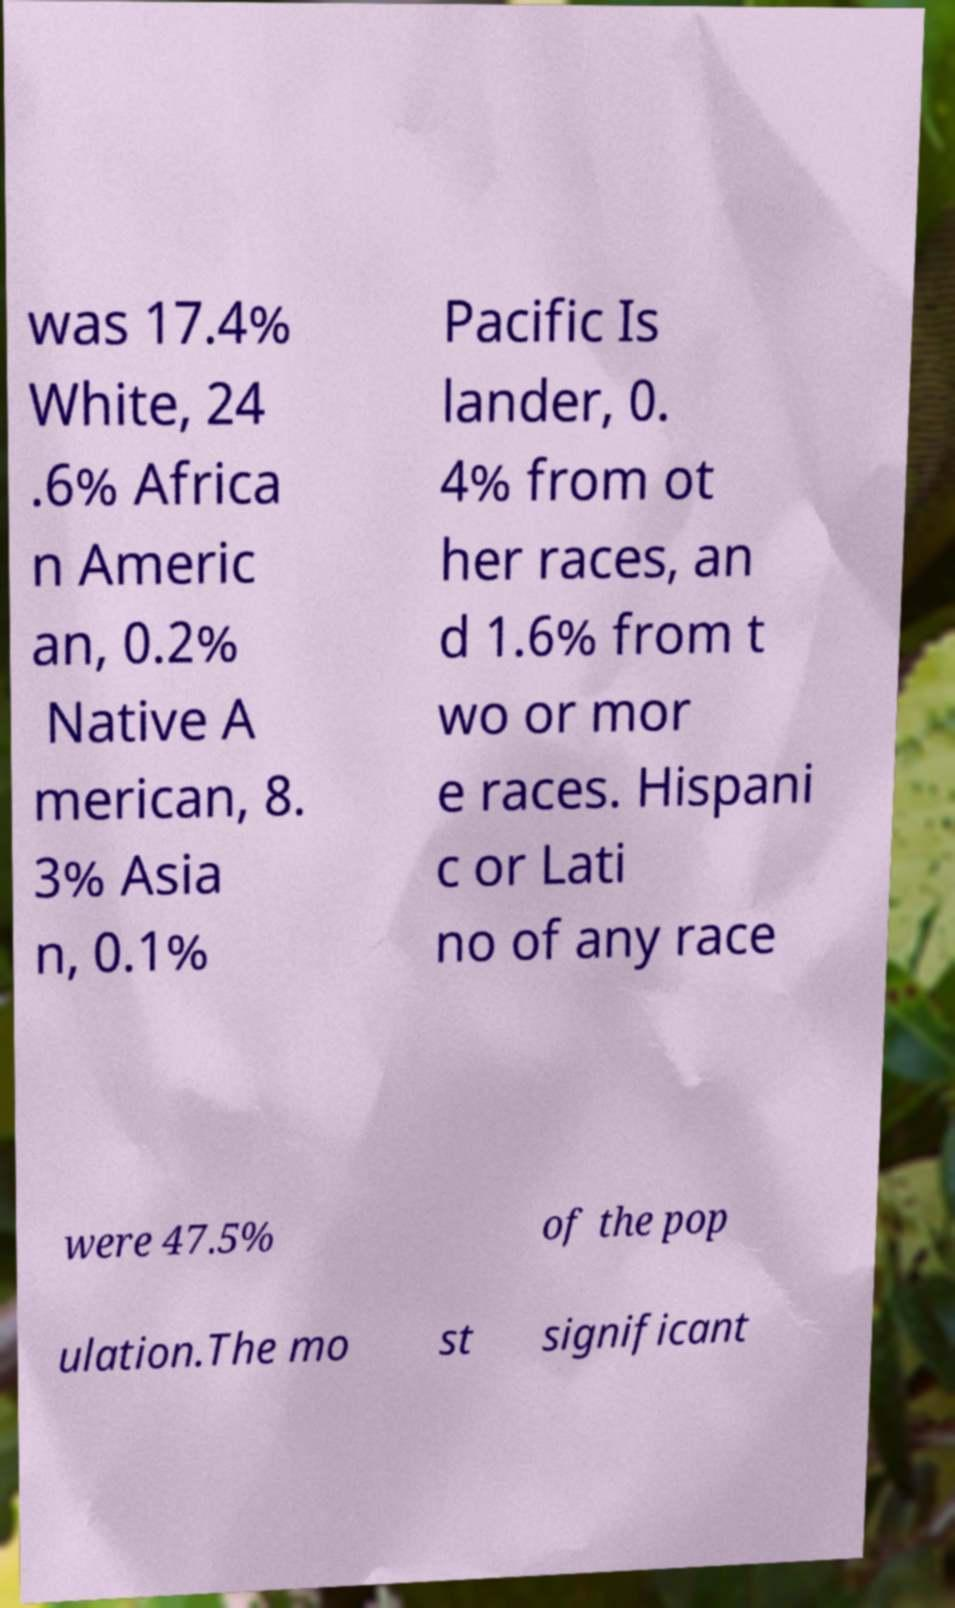I need the written content from this picture converted into text. Can you do that? was 17.4% White, 24 .6% Africa n Americ an, 0.2% Native A merican, 8. 3% Asia n, 0.1% Pacific Is lander, 0. 4% from ot her races, an d 1.6% from t wo or mor e races. Hispani c or Lati no of any race were 47.5% of the pop ulation.The mo st significant 